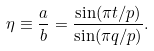<formula> <loc_0><loc_0><loc_500><loc_500>\eta \equiv \frac { a } { b } = \frac { \sin ( \pi t / p ) } { \sin ( \pi q / p ) } .</formula> 